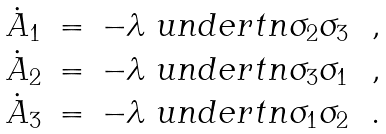<formula> <loc_0><loc_0><loc_500><loc_500>\begin{array} { r c l } { \dot { A } } _ { 1 } & = & - \lambda { \ u n d e r t n } \sigma _ { 2 } \sigma _ { 3 } \ \ , \\ { \dot { A } } _ { 2 } & = & - \lambda { \ u n d e r t n } \sigma _ { 3 } \sigma _ { 1 } \ \ , \\ { \dot { A } } _ { 3 } & = & - \lambda { \ u n d e r t n } \sigma _ { 1 } \sigma _ { 2 } \ \ . \end{array}</formula> 